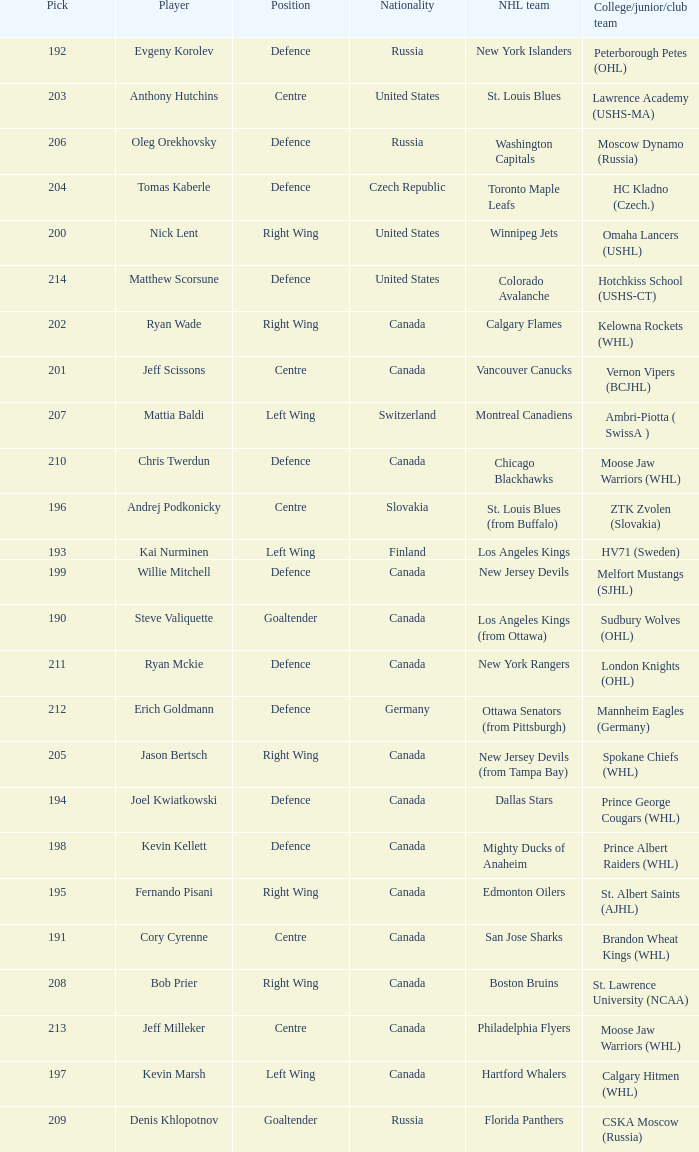Name the college for andrej podkonicky ZTK Zvolen (Slovakia). 